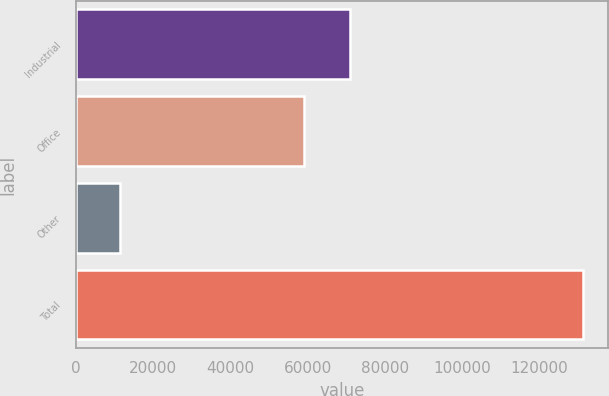Convert chart to OTSL. <chart><loc_0><loc_0><loc_500><loc_500><bar_chart><fcel>Industrial<fcel>Office<fcel>Other<fcel>Total<nl><fcel>70860.4<fcel>58881<fcel>11400<fcel>131194<nl></chart> 